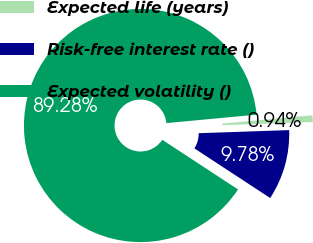Convert chart. <chart><loc_0><loc_0><loc_500><loc_500><pie_chart><fcel>Expected life (years)<fcel>Risk-free interest rate ()<fcel>Expected volatility ()<nl><fcel>0.94%<fcel>9.78%<fcel>89.28%<nl></chart> 